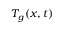Convert formula to latex. <formula><loc_0><loc_0><loc_500><loc_500>T _ { g } ( x , t )</formula> 